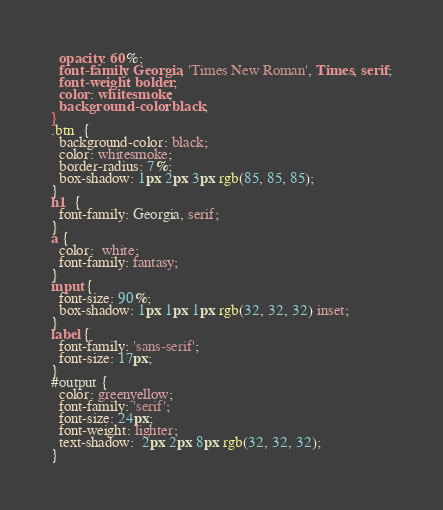<code> <loc_0><loc_0><loc_500><loc_500><_CSS_>  opacity: 60%;
  font-family: Georgia, 'Times New Roman', Times, serif;
  font-weight: bolder;
  color: whitesmoke;
  background-color: black;
}
.btn  {
  background-color: black;
  color: whitesmoke;
  border-radius: 7%;
  box-shadow: 1px 2px 3px rgb(85, 85, 85);
}
h1  {
  font-family: Georgia, serif;
}
a {
  color:  white;
  font-family: fantasy;
}
input {
  font-size: 90%;
  box-shadow: 1px 1px 1px rgb(32, 32, 32) inset;
}
label {
  font-family: 'sans-serif';
  font-size: 17px;
}
#output {
  color: greenyellow;
  font-family: 'serif';
  font-size: 24px;
  font-weight: lighter;
  text-shadow:  2px 2px 8px rgb(32, 32, 32);
}</code> 